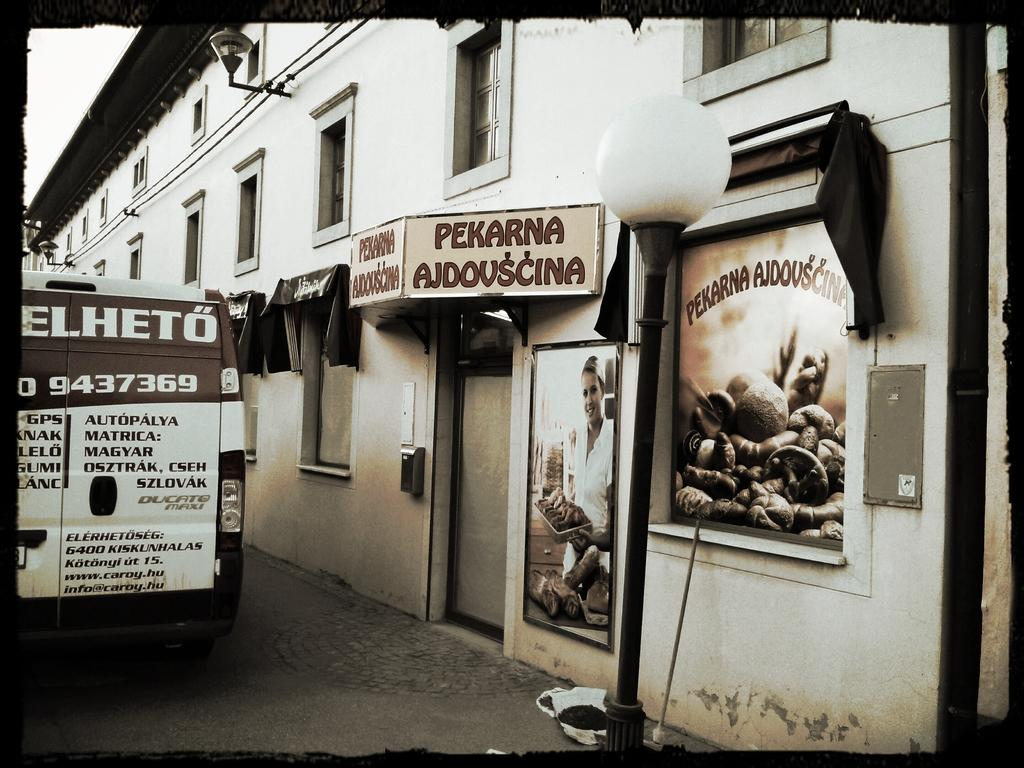<image>
Provide a brief description of the given image. A black and white photo of the Pekarna Ajdovscina business. 